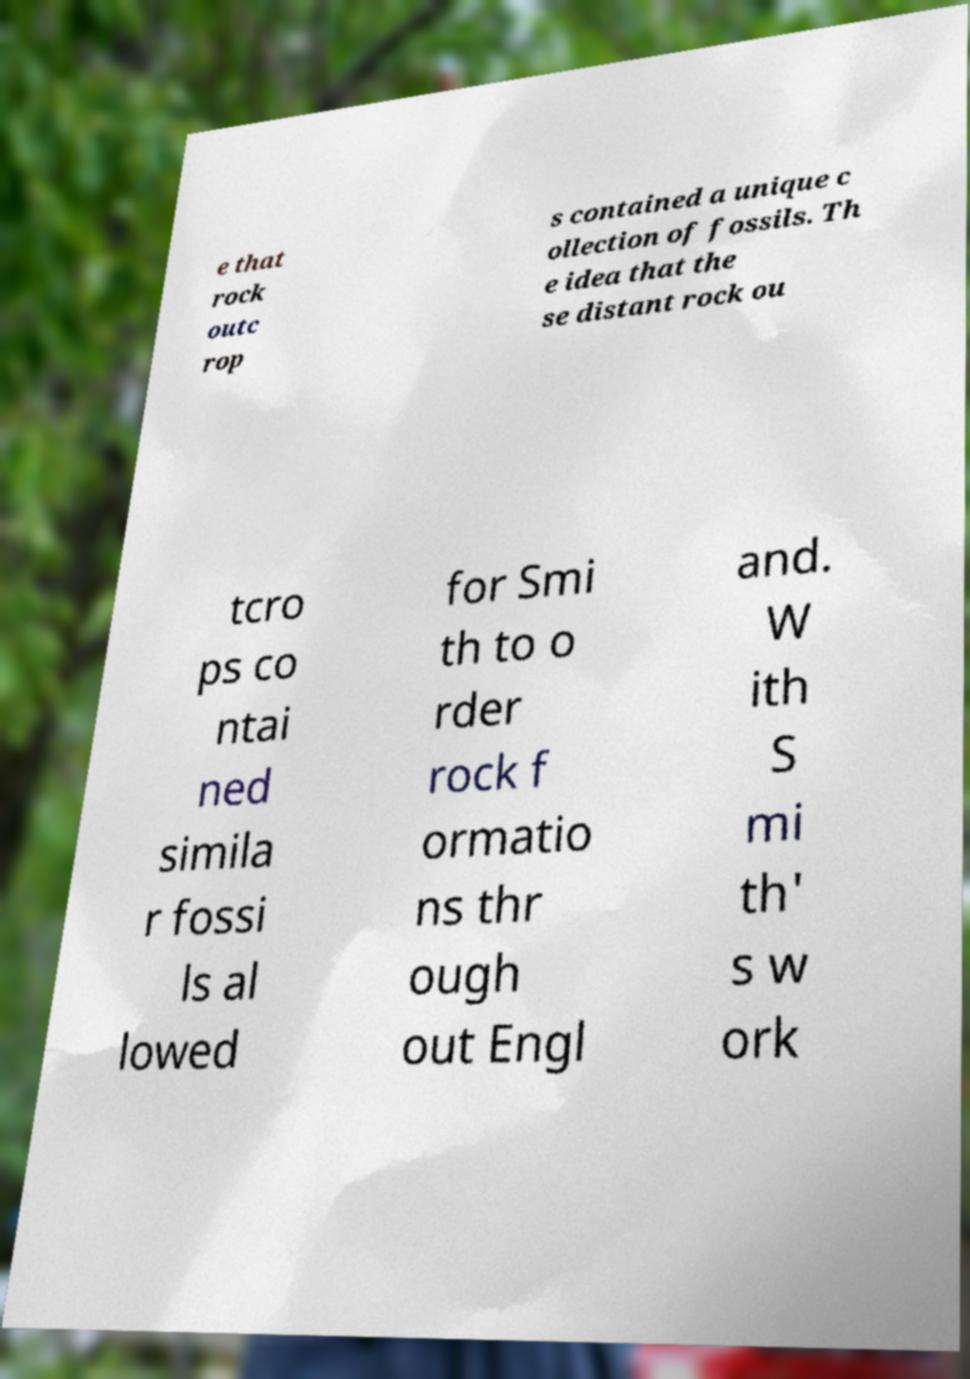Can you read and provide the text displayed in the image?This photo seems to have some interesting text. Can you extract and type it out for me? e that rock outc rop s contained a unique c ollection of fossils. Th e idea that the se distant rock ou tcro ps co ntai ned simila r fossi ls al lowed for Smi th to o rder rock f ormatio ns thr ough out Engl and. W ith S mi th' s w ork 